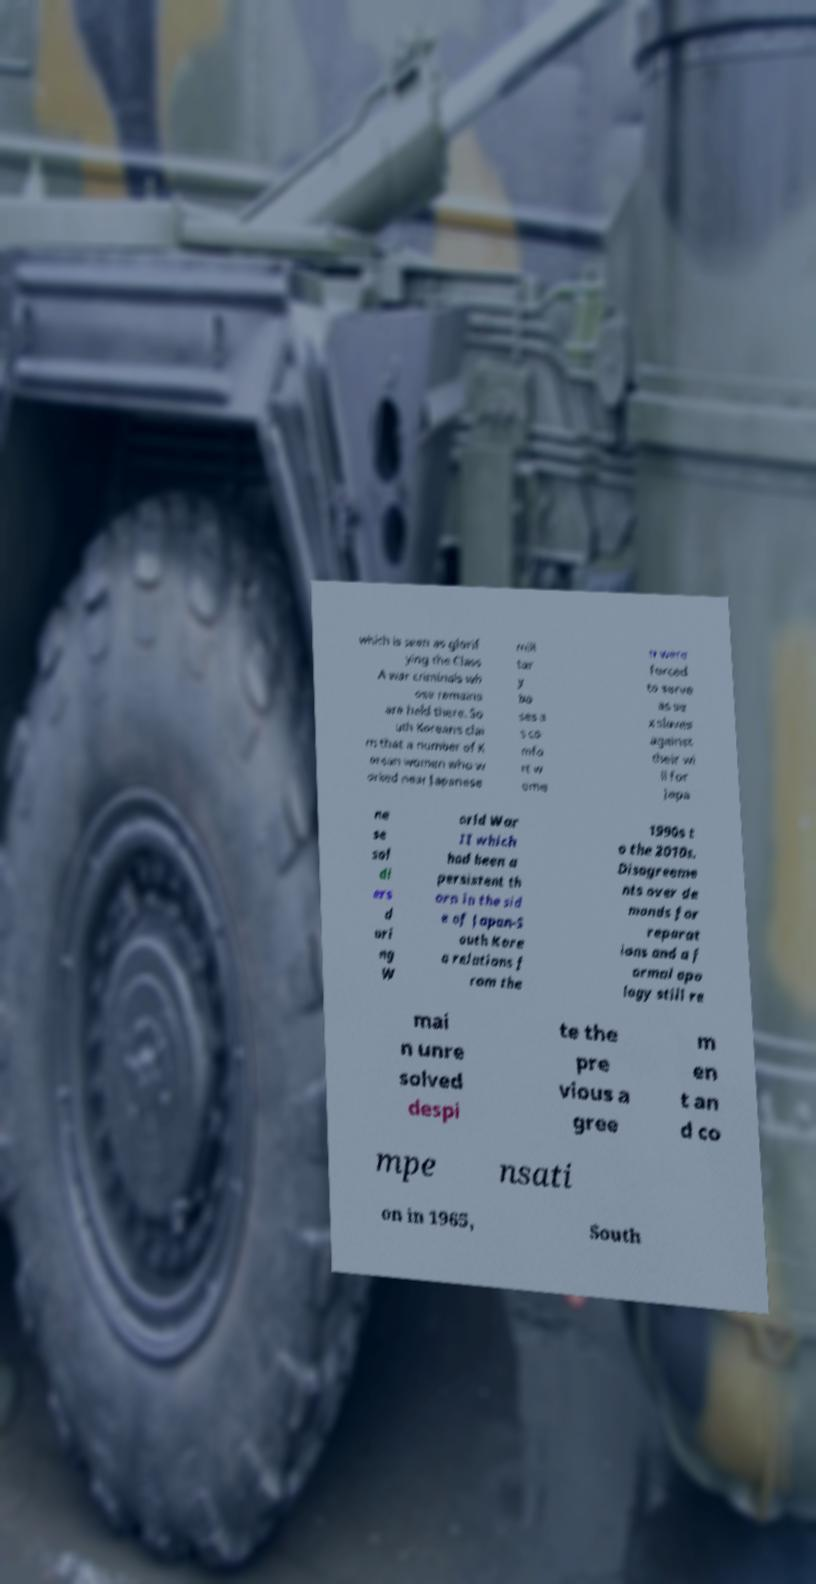Could you extract and type out the text from this image? which is seen as glorif ying the Class A war criminals wh ose remains are held there. So uth Koreans clai m that a number of K orean women who w orked near Japanese mili tar y ba ses a s co mfo rt w ome n were forced to serve as se x slaves against their wi ll for Japa ne se sol di ers d uri ng W orld War II which had been a persistent th orn in the sid e of Japan-S outh Kore a relations f rom the 1990s t o the 2010s. Disagreeme nts over de mands for reparat ions and a f ormal apo logy still re mai n unre solved despi te the pre vious a gree m en t an d co mpe nsati on in 1965, South 